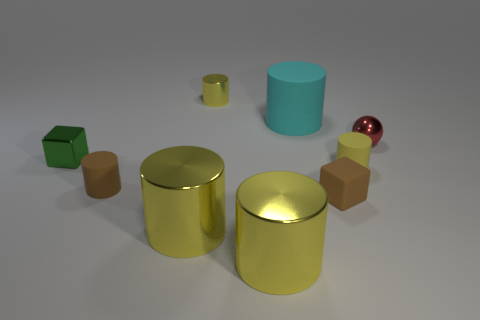What is the size of the matte thing that is the same color as the rubber block?
Your response must be concise. Small. There is a metal ball that is the same size as the green metallic cube; what color is it?
Ensure brevity in your answer.  Red. The yellow thing that is behind the brown cylinder and in front of the tiny shiny block has what shape?
Offer a very short reply. Cylinder. There is a brown matte object that is right of the yellow thing that is behind the small ball; what size is it?
Make the answer very short. Small. What number of other small cubes have the same color as the tiny metal cube?
Offer a very short reply. 0. How many other objects are the same size as the cyan rubber cylinder?
Make the answer very short. 2. What size is the matte cylinder that is in front of the green object and to the right of the brown cylinder?
Offer a very short reply. Small. What number of green metallic objects are the same shape as the small red thing?
Keep it short and to the point. 0. What is the green thing made of?
Ensure brevity in your answer.  Metal. Do the cyan rubber object and the yellow matte object have the same shape?
Give a very brief answer. Yes. 